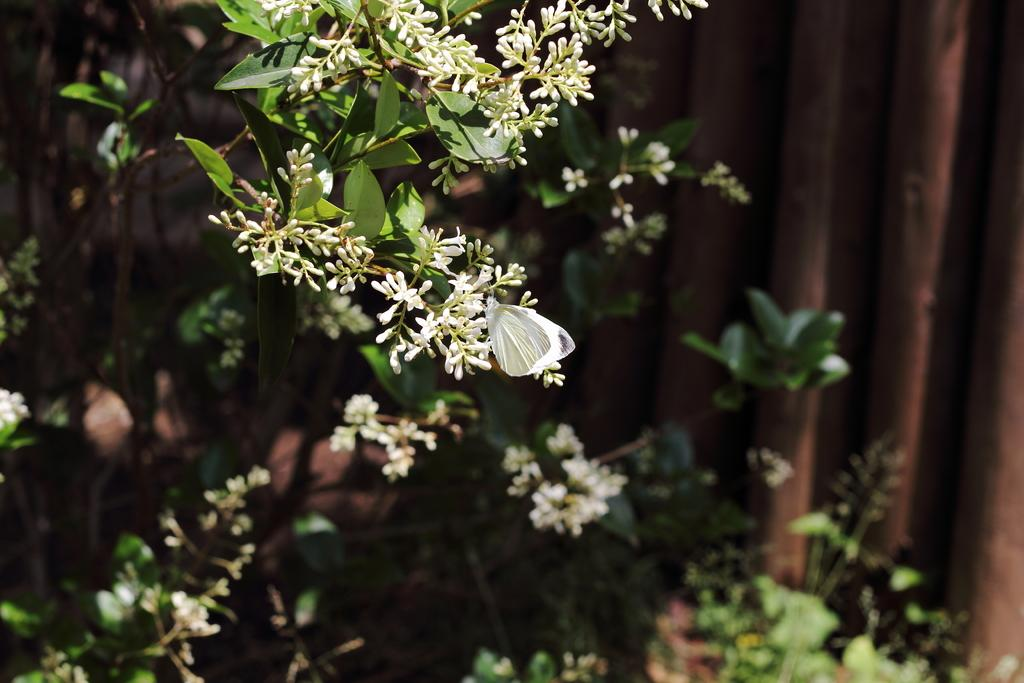What type of living organisms can be seen in the image? Plants can be seen in the image. What specific feature of the plants is visible? The plants have flowers. What type of glass object is visible in the image? There is no glass object present in the image; it only features plants with flowers. What type of rose can be seen in the image? There is no rose present in the image; the plants have flowers, but the specific type of flower is not mentioned. 